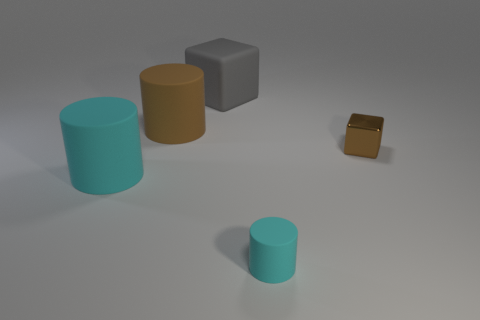How big is the cyan object on the left side of the cyan matte thing that is in front of the big cyan cylinder?
Your answer should be very brief. Large. How many things are either tiny shiny cubes that are in front of the big brown matte cylinder or tiny red rubber things?
Your answer should be very brief. 1. Is there a cyan matte cylinder that has the same size as the brown cube?
Ensure brevity in your answer.  Yes. There is a cyan rubber cylinder right of the big cyan rubber thing; is there a cyan rubber object in front of it?
Your response must be concise. No. What number of balls are either big brown things or large gray things?
Give a very brief answer. 0. Are there any other cyan rubber objects of the same shape as the small cyan matte object?
Offer a terse response. Yes. What is the shape of the tiny brown shiny thing?
Your response must be concise. Cube. How many objects are large green balls or cyan things?
Ensure brevity in your answer.  2. There is a cylinder that is behind the brown cube; does it have the same size as the cyan matte cylinder that is on the right side of the big rubber cube?
Provide a short and direct response. No. How many other things are there of the same material as the brown cylinder?
Your answer should be compact. 3. 